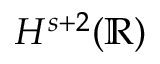Convert formula to latex. <formula><loc_0><loc_0><loc_500><loc_500>H ^ { s + 2 } ( \mathbb { R } )</formula> 